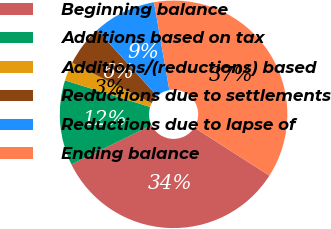Convert chart. <chart><loc_0><loc_0><loc_500><loc_500><pie_chart><fcel>Beginning balance<fcel>Additions based on tax<fcel>Additions/(reductions) based<fcel>Reductions due to settlements<fcel>Reductions due to lapse of<fcel>Ending balance<nl><fcel>33.67%<fcel>12.09%<fcel>2.66%<fcel>5.81%<fcel>8.95%<fcel>36.81%<nl></chart> 